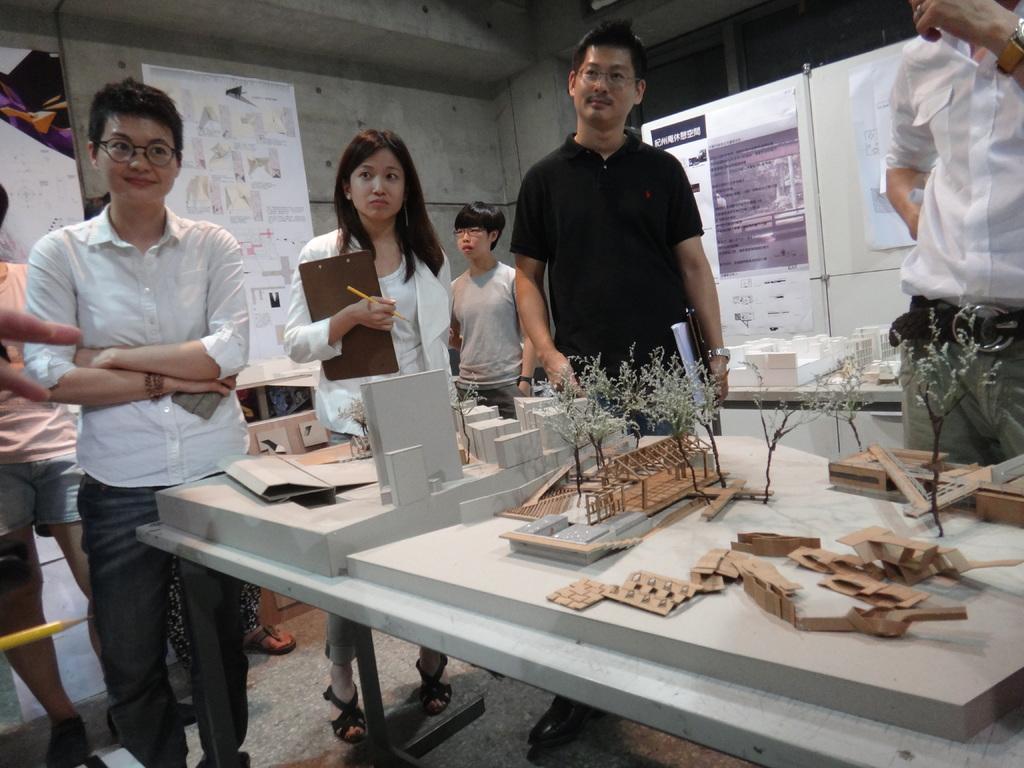How would you summarize this image in a sentence or two? In this picture we can see some people are standing on the floor and a woman holding a writing pad. In front of them on the table we can see models of trees, cardboard sheets, wooden pieces and blocks. In the background we can see the walls, posters and some objects. 